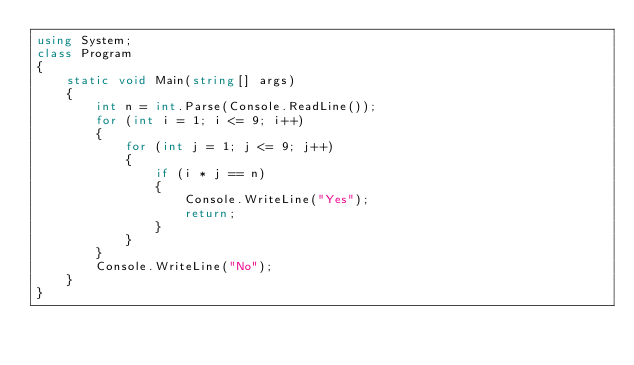Convert code to text. <code><loc_0><loc_0><loc_500><loc_500><_C#_>using System;
class Program
{
    static void Main(string[] args)
    {
        int n = int.Parse(Console.ReadLine());
        for (int i = 1; i <= 9; i++)
        {
            for (int j = 1; j <= 9; j++)
            {
                if (i * j == n)
                {
                    Console.WriteLine("Yes");
                    return;
                }
            }
        }
        Console.WriteLine("No");
    }
}</code> 